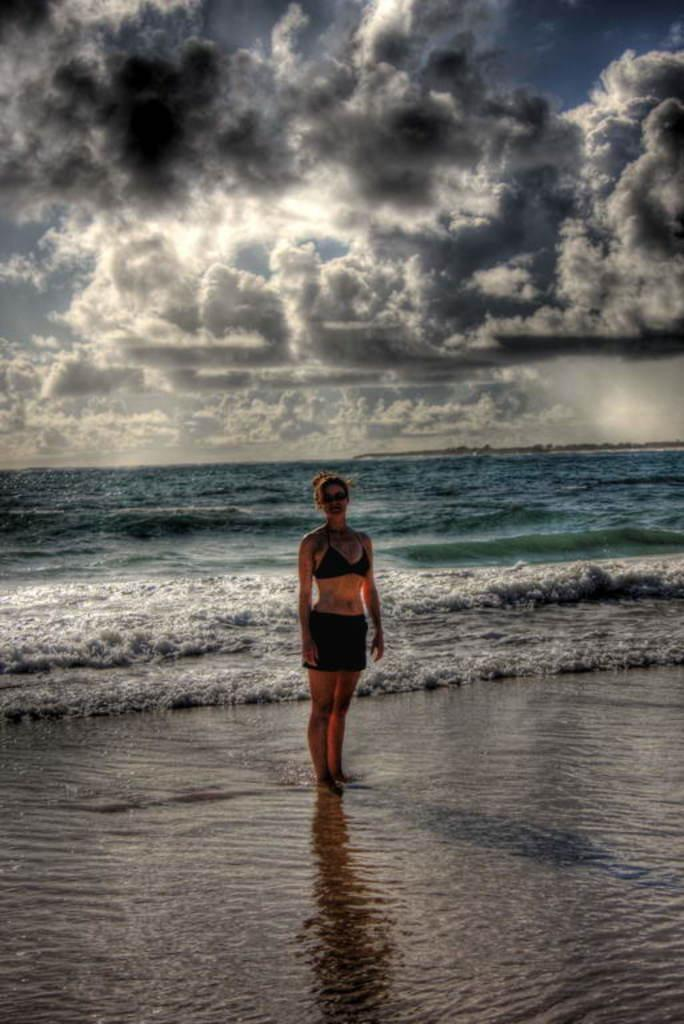What can you describe the sky in the image? The sky with clouds is visible in the image. What is the main body of water in the image? There is an ocean in the image. Is there any land visible in the image? Yes, there is a person standing on the sea shore in the image. Who is the owner of the tomatoes in the image? There are no tomatoes present in the image, so it is not possible to determine an owner. 